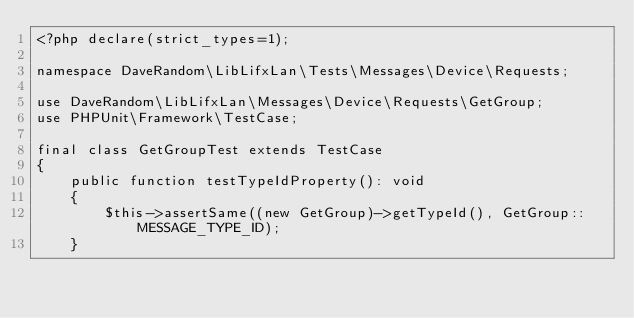Convert code to text. <code><loc_0><loc_0><loc_500><loc_500><_PHP_><?php declare(strict_types=1);

namespace DaveRandom\LibLifxLan\Tests\Messages\Device\Requests;

use DaveRandom\LibLifxLan\Messages\Device\Requests\GetGroup;
use PHPUnit\Framework\TestCase;

final class GetGroupTest extends TestCase
{
    public function testTypeIdProperty(): void
    {
        $this->assertSame((new GetGroup)->getTypeId(), GetGroup::MESSAGE_TYPE_ID);
    }
</code> 